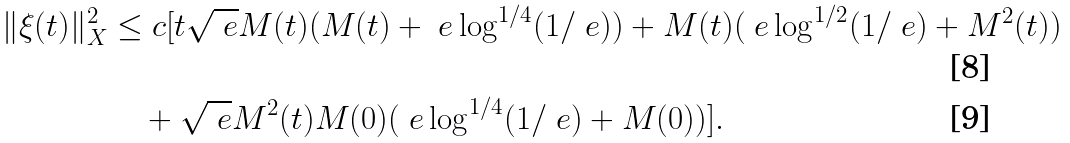<formula> <loc_0><loc_0><loc_500><loc_500>\| \xi ( t ) \| _ { X } ^ { 2 } & \leq c [ t \sqrt { \ e } M ( t ) ( M ( t ) + \ e \log ^ { 1 / 4 } ( 1 / \ e ) ) + M ( t ) ( \ e \log ^ { 1 / 2 } ( 1 / \ e ) + M ^ { 2 } ( t ) ) \\ & \quad + \sqrt { \ e } M ^ { 2 } ( t ) M ( 0 ) ( \ e \log ^ { 1 / 4 } ( 1 / \ e ) + M ( 0 ) ) ] .</formula> 